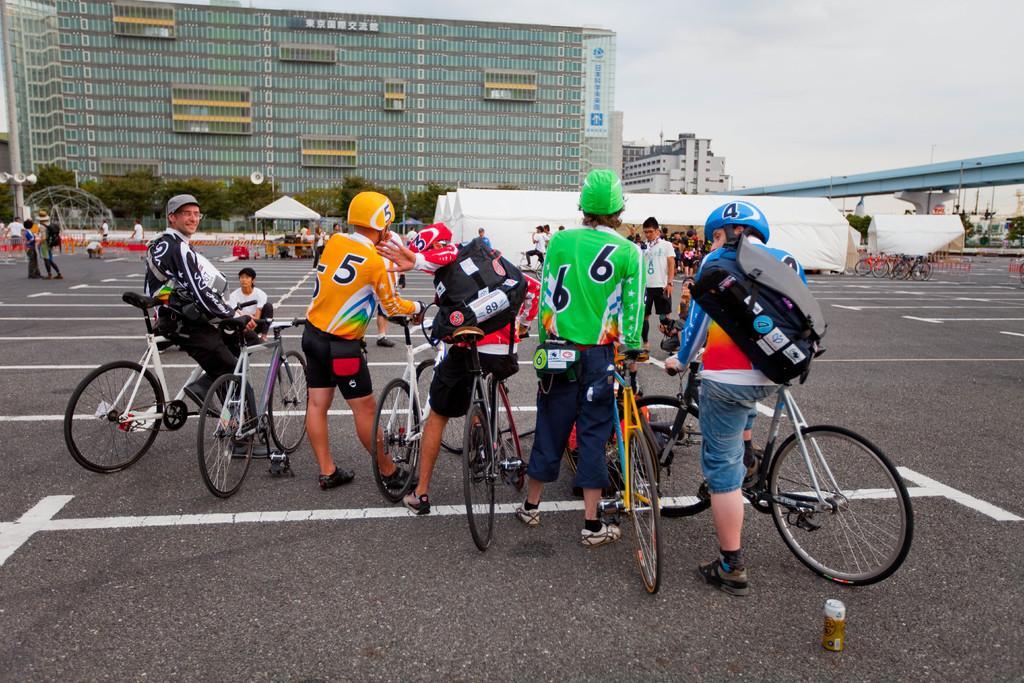Please provide a concise description of this image. In this picture we can see some people are standing and holding bicycle, side we can see some buildings, tents and few people. 